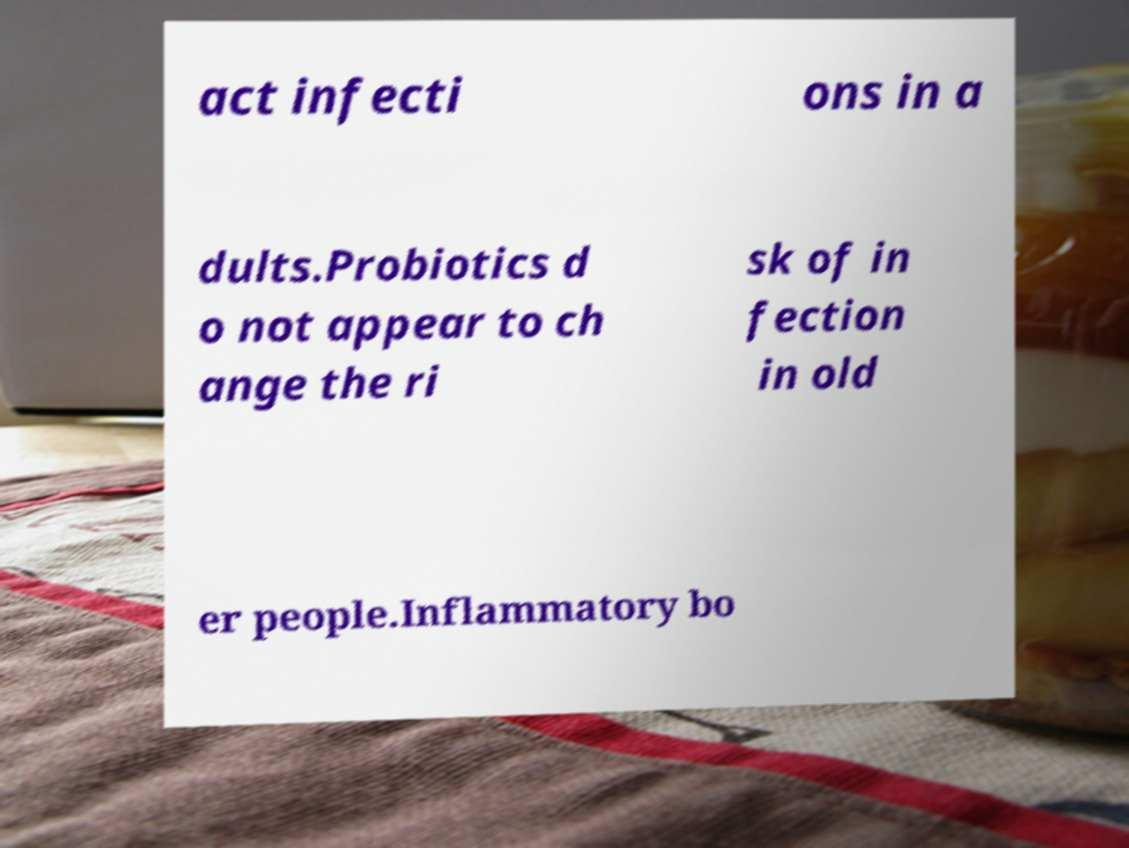Please read and relay the text visible in this image. What does it say? act infecti ons in a dults.Probiotics d o not appear to ch ange the ri sk of in fection in old er people.Inflammatory bo 